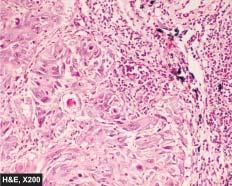what are seen?
Answer the question using a single word or phrase. Islands of invading malignant squamous cells 